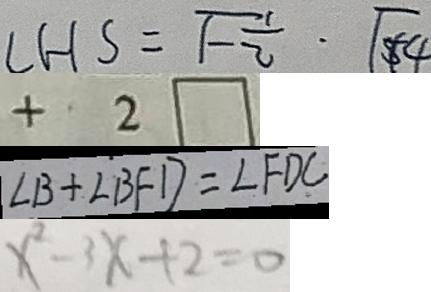<formula> <loc_0><loc_0><loc_500><loc_500>L H S = \sqrt { - \frac { 1 } { 2 } } \cdot \sqrt { 4 } 
 + 2 \square 
 \angle B + \angle B F D = \angle F D C 
 x ^ { 2 } - 3 x + 2 = 0</formula> 